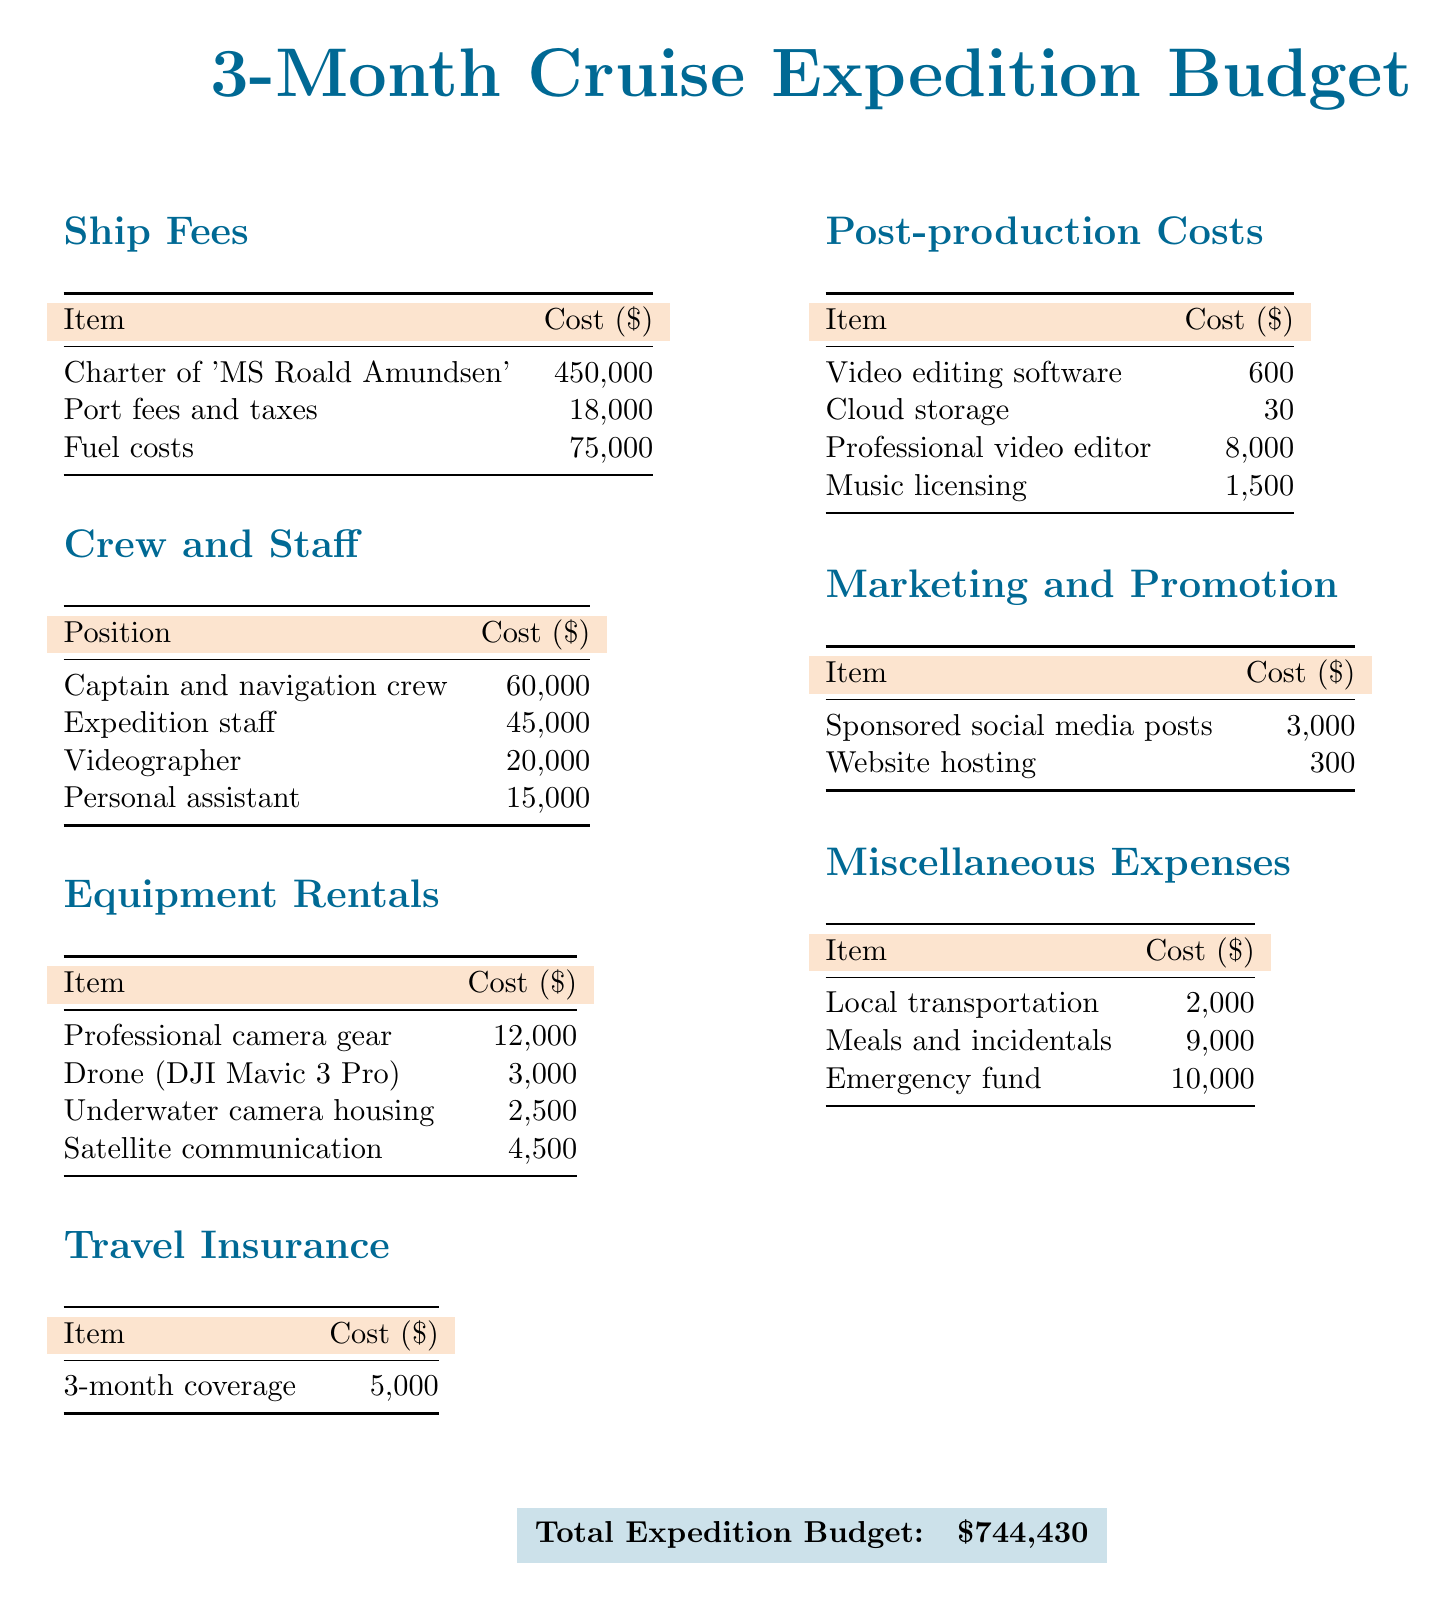What is the total expedition budget? The total expedition budget is presented at the end of the document, summing all costs outlined.
Answer: $744,430 How much does the charter of 'MS Roald Amundsen' cost? The cost for the charter is specified in the Ship Fees section of the document.
Answer: $450,000 What is the cost of meals and incidentals? This expense is listed in the Miscellaneous Expenses section and reflects the total for food and related costs.
Answer: $9,000 How much is allocated for the professional video editor? The document indicates the cost for hiring a professional video editor in the Post-production Costs section.
Answer: $8,000 What is the total cost of travel insurance? The document specifies the cost of travel insurance for a three-month coverage.
Answer: $5,000 What is included in the Equipment Rentals expenses? The Equipment Rentals section lists specific items and their corresponding costs, totaling various necessary equipment.
Answer: Professional camera gear, Drone (DJI Mavic 3 Pro), Underwater camera housing, Satellite communication How much is spent on marketing and promotion? The total costs related to marketing and promotion are detailed in their respective section.
Answer: $3,300 What position has the highest cost in the Crew and Staff section? By comparing all positions listed in that section, we can identify which has the highest cost.
Answer: Captain and navigation crew What is the cost of cloud storage? Cloud storage is outlined in the Post-production Costs and shows its specific allocation.
Answer: $30 